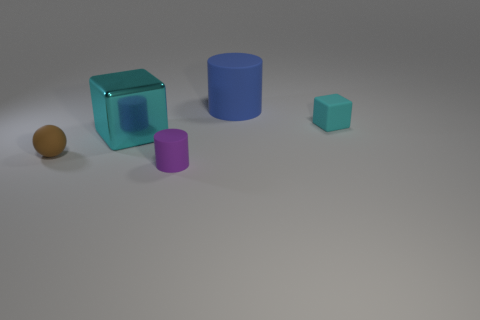Add 3 big blocks. How many objects exist? 8 Subtract all cylinders. How many objects are left? 3 Subtract 0 purple cubes. How many objects are left? 5 Subtract all gray metallic blocks. Subtract all cyan metallic cubes. How many objects are left? 4 Add 1 purple rubber cylinders. How many purple rubber cylinders are left? 2 Add 1 large purple metal spheres. How many large purple metal spheres exist? 1 